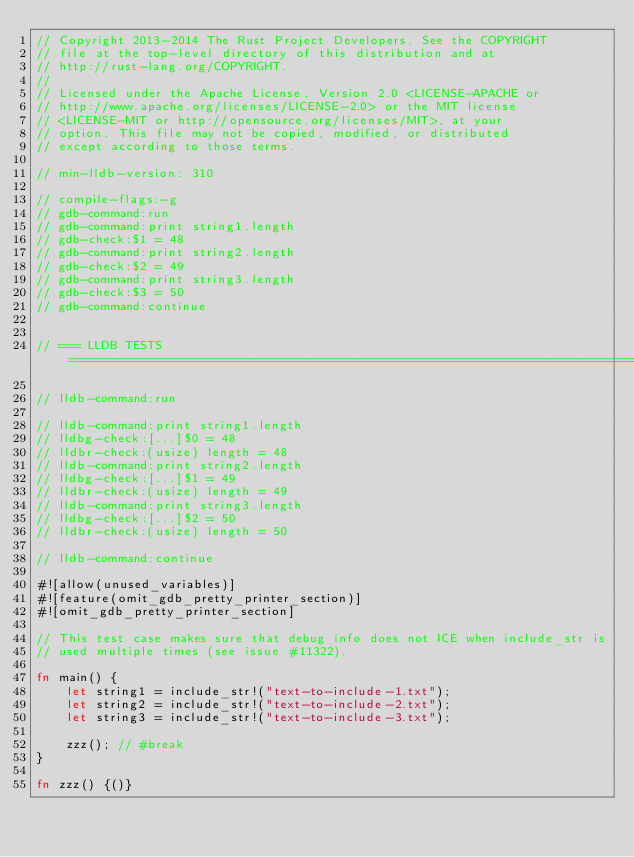Convert code to text. <code><loc_0><loc_0><loc_500><loc_500><_Rust_>// Copyright 2013-2014 The Rust Project Developers. See the COPYRIGHT
// file at the top-level directory of this distribution and at
// http://rust-lang.org/COPYRIGHT.
//
// Licensed under the Apache License, Version 2.0 <LICENSE-APACHE or
// http://www.apache.org/licenses/LICENSE-2.0> or the MIT license
// <LICENSE-MIT or http://opensource.org/licenses/MIT>, at your
// option. This file may not be copied, modified, or distributed
// except according to those terms.

// min-lldb-version: 310

// compile-flags:-g
// gdb-command:run
// gdb-command:print string1.length
// gdb-check:$1 = 48
// gdb-command:print string2.length
// gdb-check:$2 = 49
// gdb-command:print string3.length
// gdb-check:$3 = 50
// gdb-command:continue


// === LLDB TESTS ==================================================================================

// lldb-command:run

// lldb-command:print string1.length
// lldbg-check:[...]$0 = 48
// lldbr-check:(usize) length = 48
// lldb-command:print string2.length
// lldbg-check:[...]$1 = 49
// lldbr-check:(usize) length = 49
// lldb-command:print string3.length
// lldbg-check:[...]$2 = 50
// lldbr-check:(usize) length = 50

// lldb-command:continue

#![allow(unused_variables)]
#![feature(omit_gdb_pretty_printer_section)]
#![omit_gdb_pretty_printer_section]

// This test case makes sure that debug info does not ICE when include_str is
// used multiple times (see issue #11322).

fn main() {
    let string1 = include_str!("text-to-include-1.txt");
    let string2 = include_str!("text-to-include-2.txt");
    let string3 = include_str!("text-to-include-3.txt");

    zzz(); // #break
}

fn zzz() {()}
</code> 